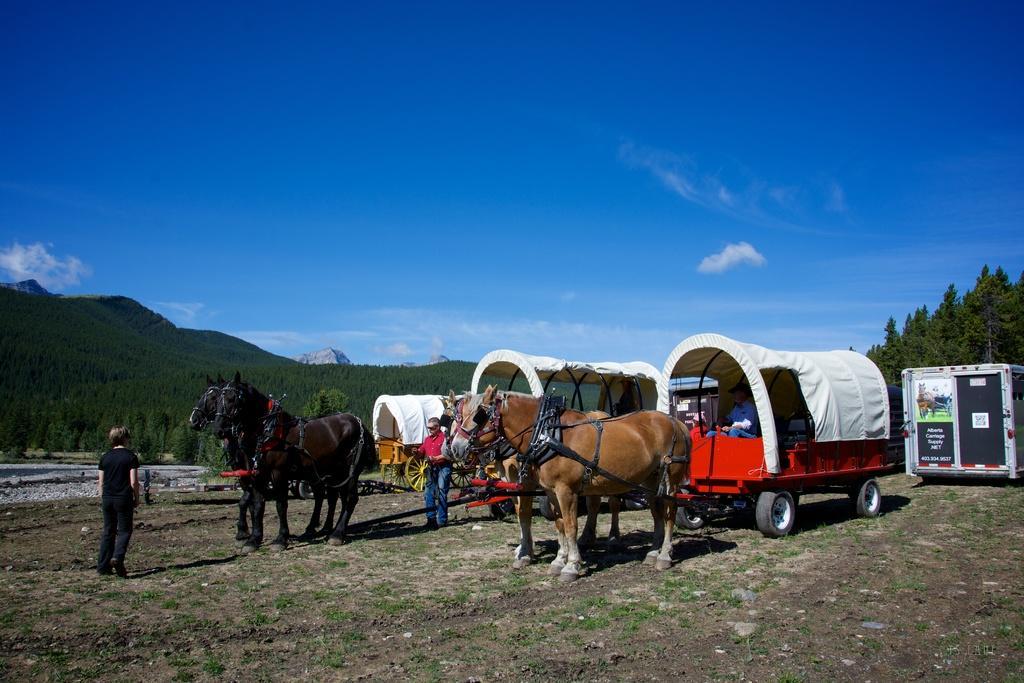How would you summarize this image in a sentence or two? In this image I can see few horses, few people and few carts. In the background I can see number of trees, clouds and the sky. Here I can see something is written. 